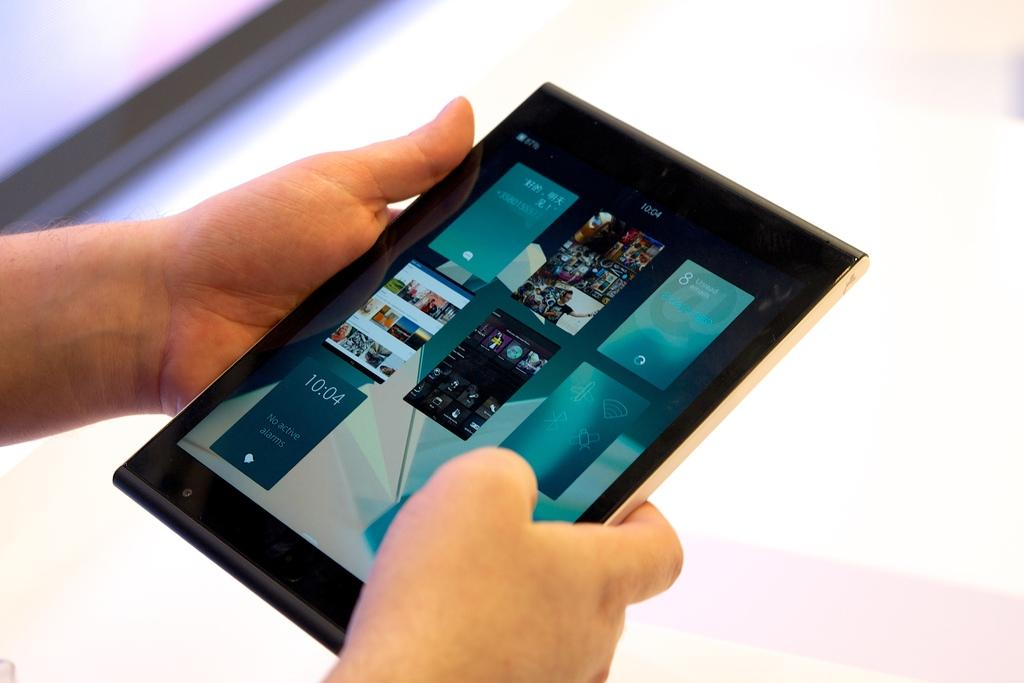Who or what is the main subject in the image? There is a person in the image. What is the person holding in the image? The person is holding a tablet. How is the person holding the tablet? The person is using both hands to hold the tablet. What type of rifle is the person using in the image? There is no rifle present in the image; the person is holding a tablet. 